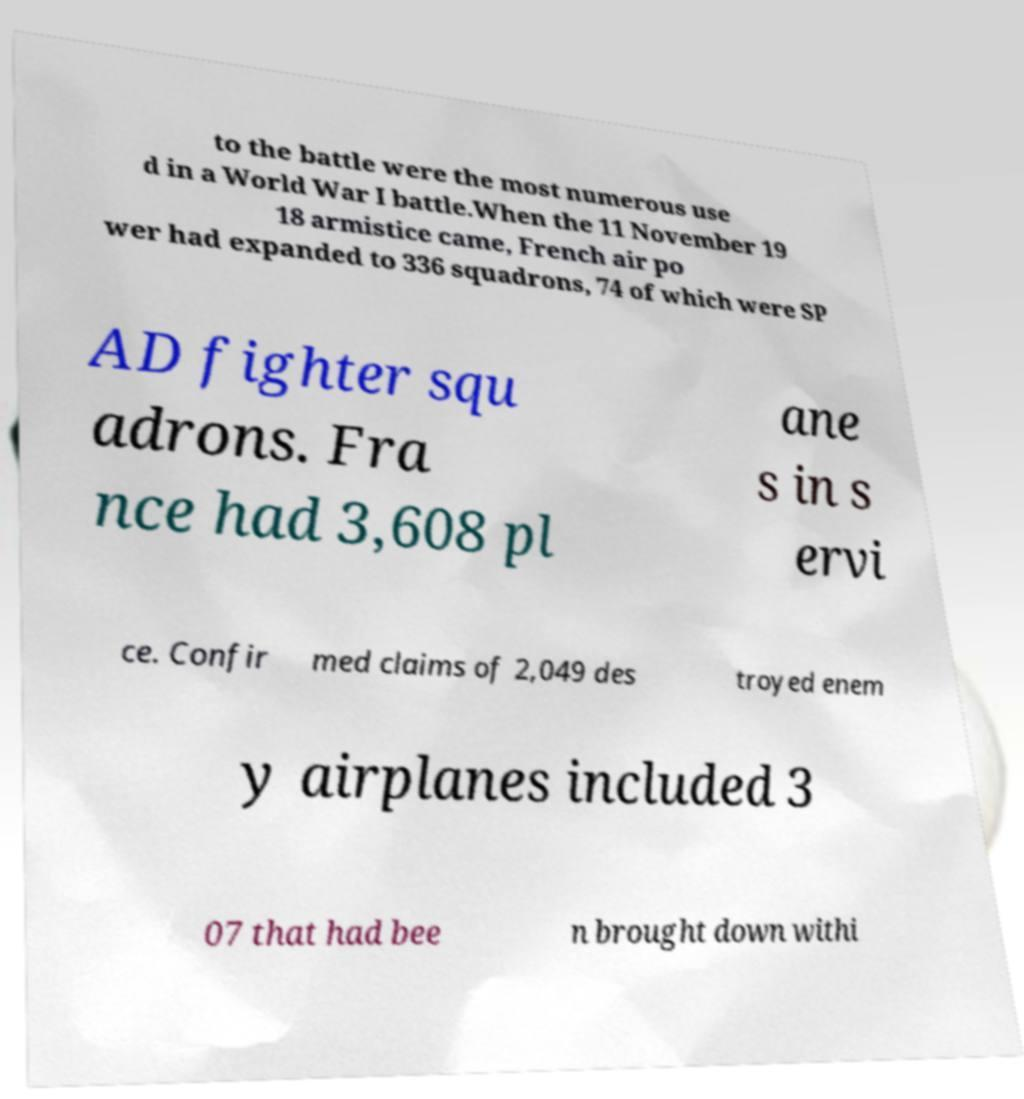Can you accurately transcribe the text from the provided image for me? to the battle were the most numerous use d in a World War I battle.When the 11 November 19 18 armistice came, French air po wer had expanded to 336 squadrons, 74 of which were SP AD fighter squ adrons. Fra nce had 3,608 pl ane s in s ervi ce. Confir med claims of 2,049 des troyed enem y airplanes included 3 07 that had bee n brought down withi 